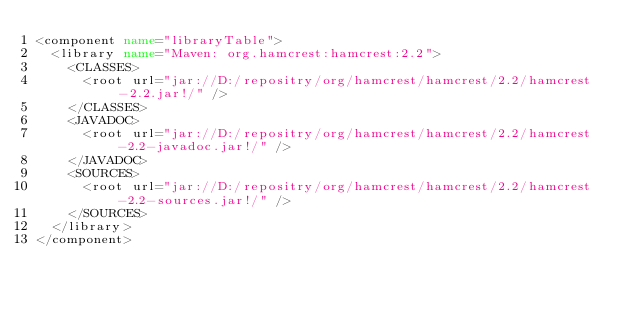Convert code to text. <code><loc_0><loc_0><loc_500><loc_500><_XML_><component name="libraryTable">
  <library name="Maven: org.hamcrest:hamcrest:2.2">
    <CLASSES>
      <root url="jar://D:/repositry/org/hamcrest/hamcrest/2.2/hamcrest-2.2.jar!/" />
    </CLASSES>
    <JAVADOC>
      <root url="jar://D:/repositry/org/hamcrest/hamcrest/2.2/hamcrest-2.2-javadoc.jar!/" />
    </JAVADOC>
    <SOURCES>
      <root url="jar://D:/repositry/org/hamcrest/hamcrest/2.2/hamcrest-2.2-sources.jar!/" />
    </SOURCES>
  </library>
</component></code> 